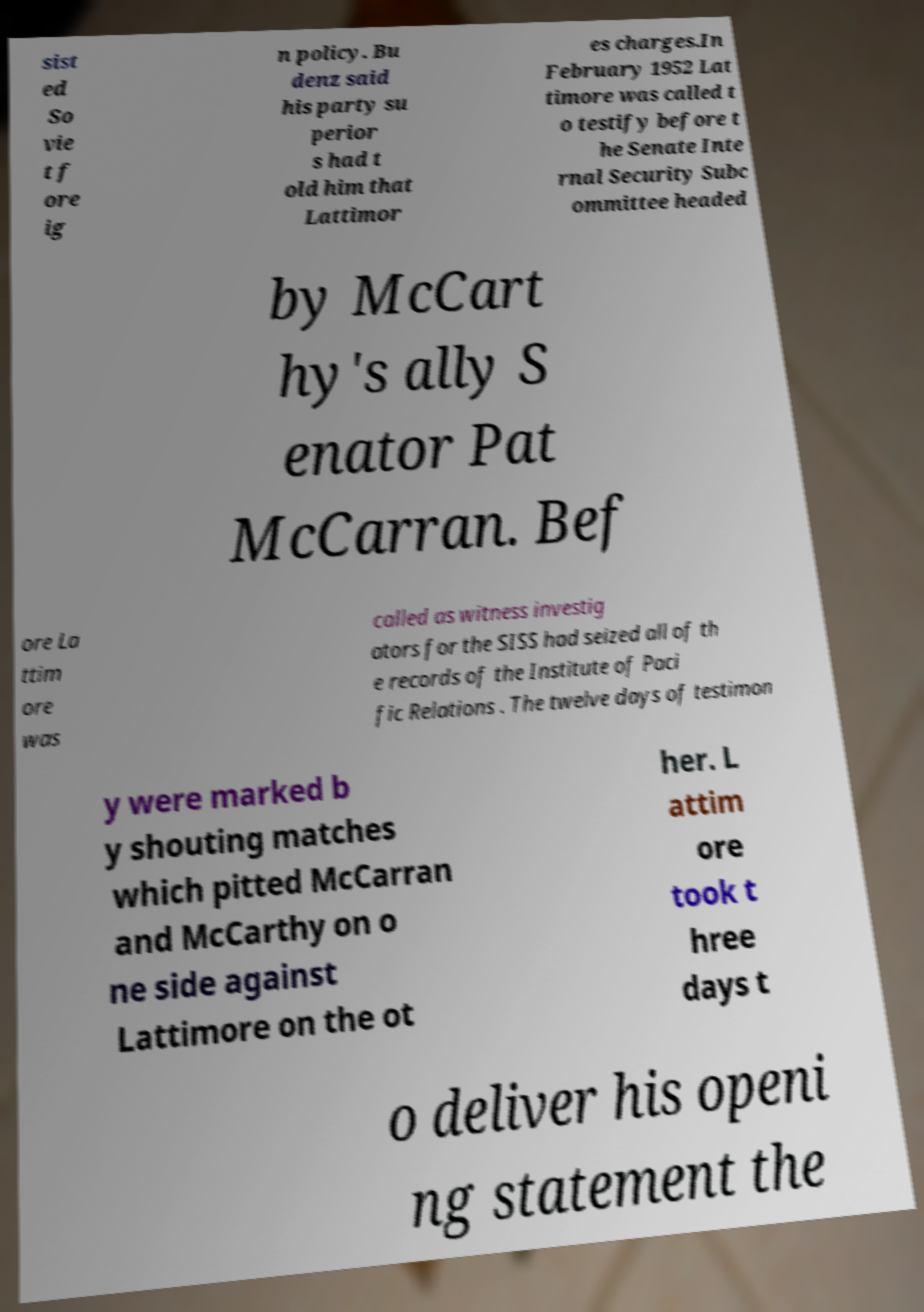For documentation purposes, I need the text within this image transcribed. Could you provide that? sist ed So vie t f ore ig n policy. Bu denz said his party su perior s had t old him that Lattimor es charges.In February 1952 Lat timore was called t o testify before t he Senate Inte rnal Security Subc ommittee headed by McCart hy's ally S enator Pat McCarran. Bef ore La ttim ore was called as witness investig ators for the SISS had seized all of th e records of the Institute of Paci fic Relations . The twelve days of testimon y were marked b y shouting matches which pitted McCarran and McCarthy on o ne side against Lattimore on the ot her. L attim ore took t hree days t o deliver his openi ng statement the 